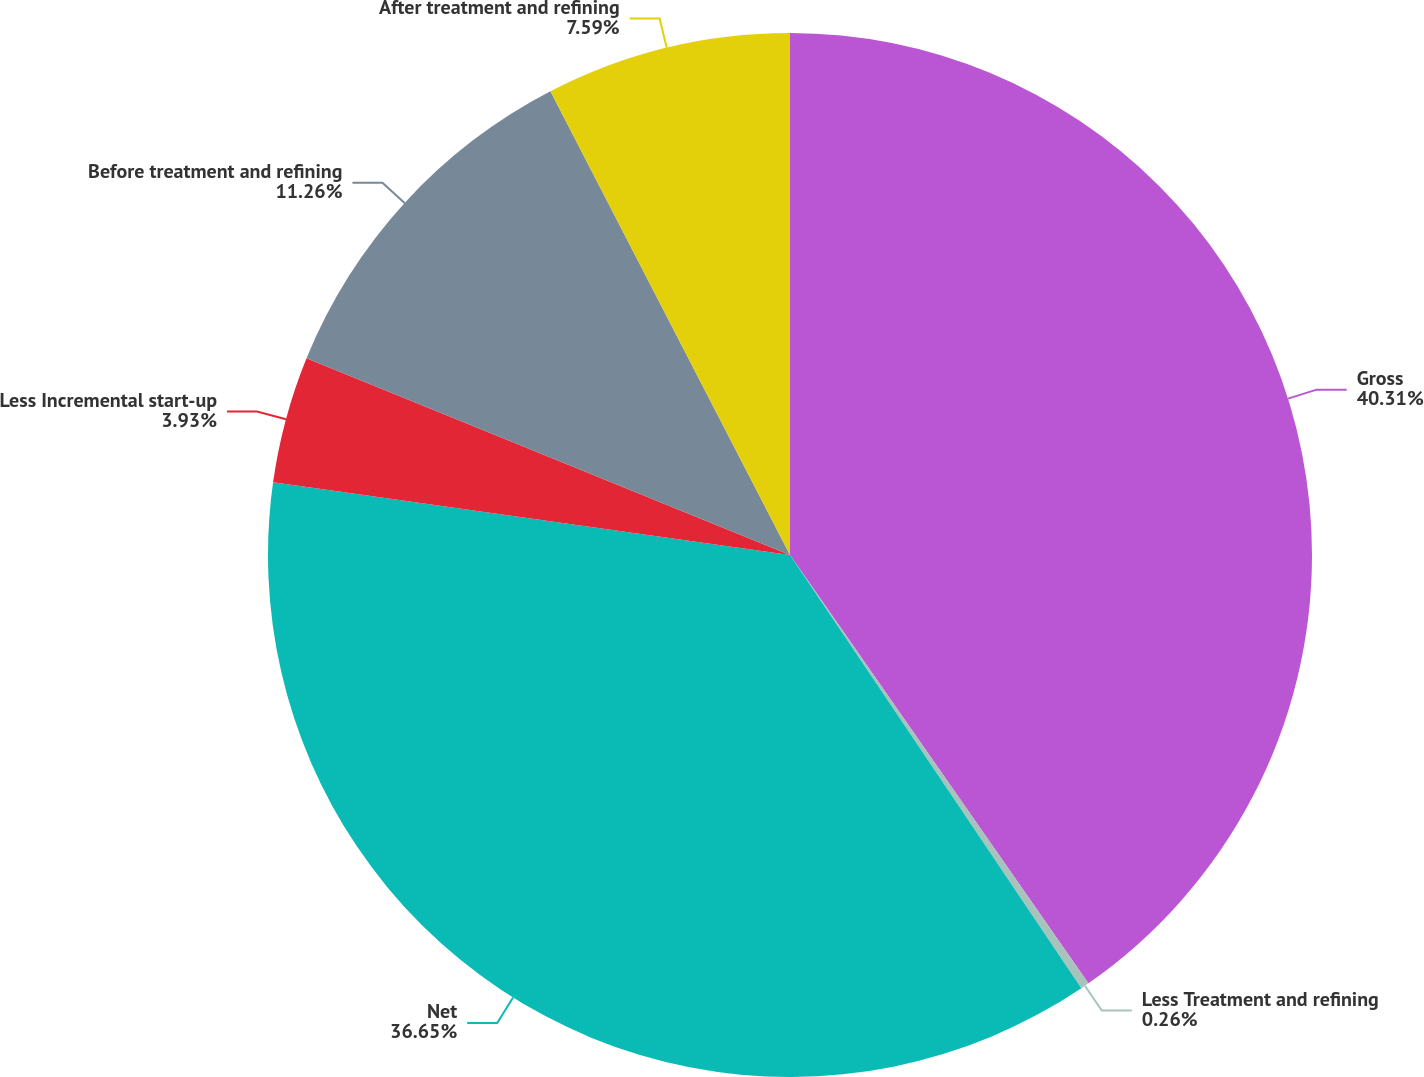Convert chart. <chart><loc_0><loc_0><loc_500><loc_500><pie_chart><fcel>Gross<fcel>Less Treatment and refining<fcel>Net<fcel>Less Incremental start-up<fcel>Before treatment and refining<fcel>After treatment and refining<nl><fcel>40.32%<fcel>0.26%<fcel>36.65%<fcel>3.93%<fcel>11.26%<fcel>7.59%<nl></chart> 